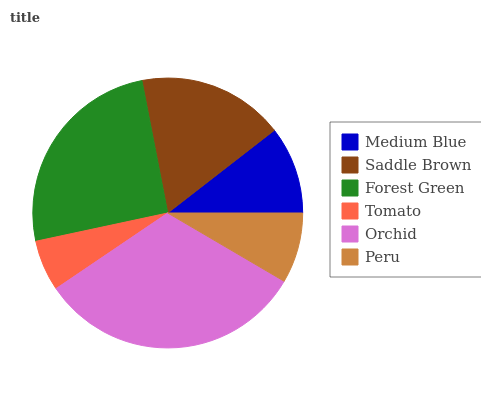Is Tomato the minimum?
Answer yes or no. Yes. Is Orchid the maximum?
Answer yes or no. Yes. Is Saddle Brown the minimum?
Answer yes or no. No. Is Saddle Brown the maximum?
Answer yes or no. No. Is Saddle Brown greater than Medium Blue?
Answer yes or no. Yes. Is Medium Blue less than Saddle Brown?
Answer yes or no. Yes. Is Medium Blue greater than Saddle Brown?
Answer yes or no. No. Is Saddle Brown less than Medium Blue?
Answer yes or no. No. Is Saddle Brown the high median?
Answer yes or no. Yes. Is Medium Blue the low median?
Answer yes or no. Yes. Is Medium Blue the high median?
Answer yes or no. No. Is Orchid the low median?
Answer yes or no. No. 